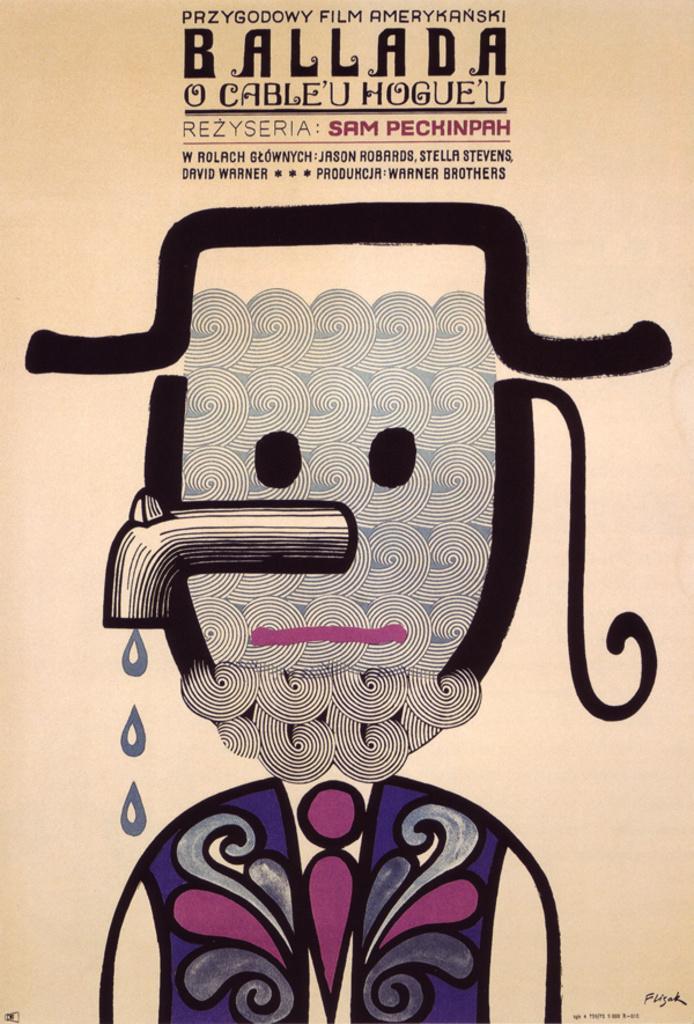In one or two sentences, can you explain what this image depicts? In this picture I can see the poster. In that poster I can see the design which looks like a man and water tap is replaced with his nose. Here we can see the water drops. In the bottom right corner I can see the signature of a person. 